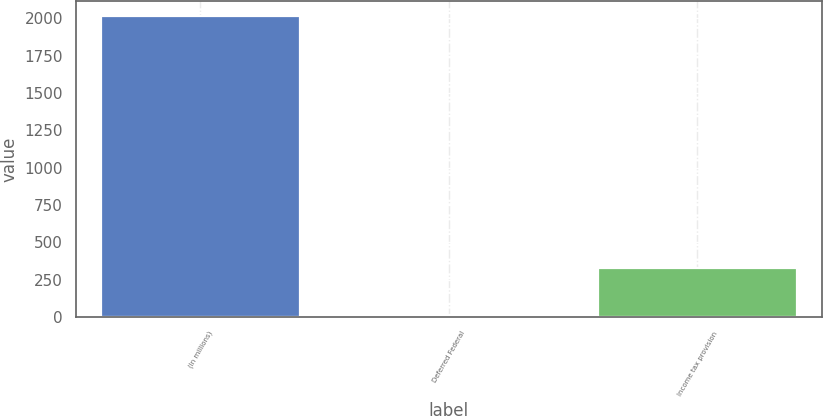Convert chart to OTSL. <chart><loc_0><loc_0><loc_500><loc_500><bar_chart><fcel>(In millions)<fcel>Deferred Federal<fcel>Income tax provision<nl><fcel>2013<fcel>12<fcel>328<nl></chart> 